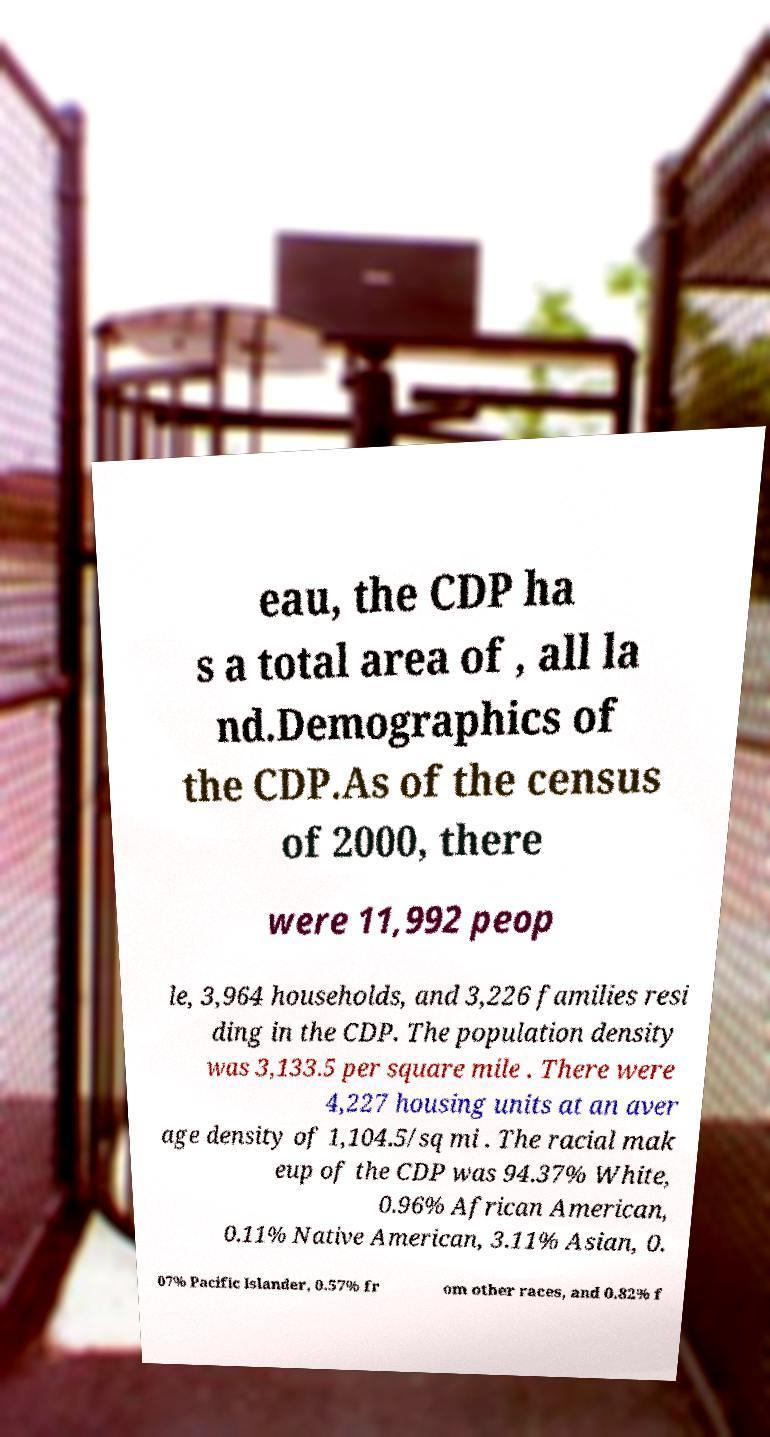Can you read and provide the text displayed in the image?This photo seems to have some interesting text. Can you extract and type it out for me? eau, the CDP ha s a total area of , all la nd.Demographics of the CDP.As of the census of 2000, there were 11,992 peop le, 3,964 households, and 3,226 families resi ding in the CDP. The population density was 3,133.5 per square mile . There were 4,227 housing units at an aver age density of 1,104.5/sq mi . The racial mak eup of the CDP was 94.37% White, 0.96% African American, 0.11% Native American, 3.11% Asian, 0. 07% Pacific Islander, 0.57% fr om other races, and 0.82% f 